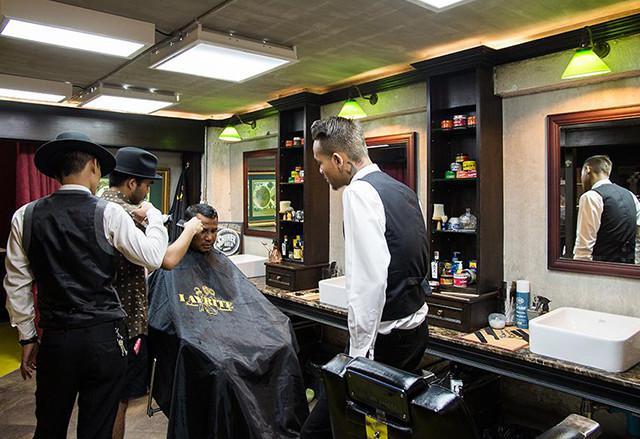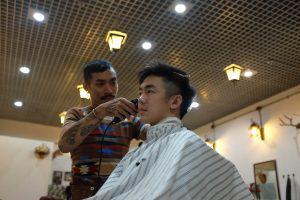The first image is the image on the left, the second image is the image on the right. Evaluate the accuracy of this statement regarding the images: "In one image three men are sitting in barber chairs, one of them bald, one wearing a hat, and one with hair and no hat.". Is it true? Answer yes or no. No. The first image is the image on the left, the second image is the image on the right. Analyze the images presented: Is the assertion "Three men are sitting in barber chairs in one of the images." valid? Answer yes or no. No. 